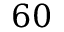Convert formula to latex. <formula><loc_0><loc_0><loc_500><loc_500>6 0</formula> 